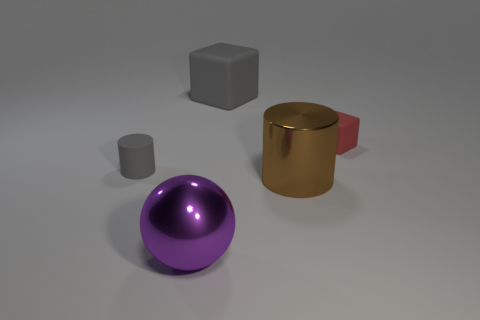How many things are gray blocks or purple metal objects?
Your response must be concise. 2. Do the cube to the left of the small red block and the small red object have the same material?
Give a very brief answer. Yes. The purple object is what size?
Provide a succinct answer. Large. What is the shape of the large thing that is the same color as the tiny cylinder?
Your answer should be very brief. Cube. How many cubes are large gray objects or purple objects?
Your answer should be very brief. 1. Is the number of tiny red rubber things in front of the purple metallic object the same as the number of big gray cubes in front of the large gray rubber object?
Your answer should be very brief. Yes. What is the size of the gray matte thing that is the same shape as the small red object?
Offer a terse response. Large. There is a object that is behind the big cylinder and in front of the small matte cube; how big is it?
Offer a terse response. Small. There is a shiny cylinder; are there any gray cubes in front of it?
Your response must be concise. No. What number of things are either big metal objects behind the big purple metallic ball or tiny red matte cylinders?
Make the answer very short. 1. 